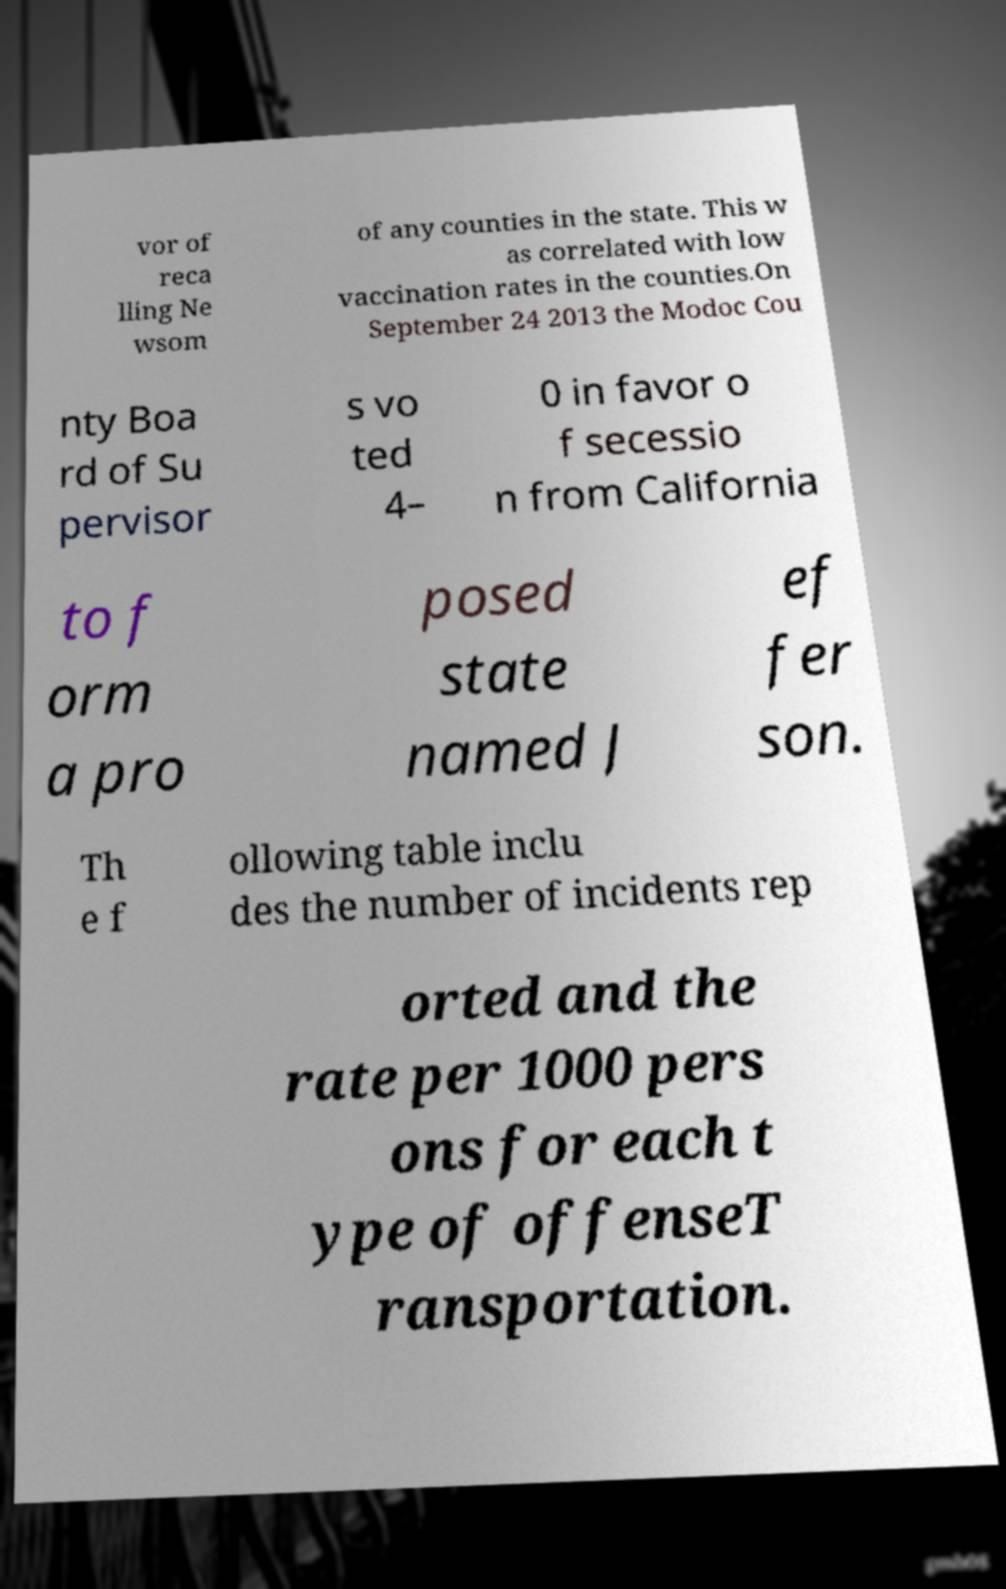Please identify and transcribe the text found in this image. vor of reca lling Ne wsom of any counties in the state. This w as correlated with low vaccination rates in the counties.On September 24 2013 the Modoc Cou nty Boa rd of Su pervisor s vo ted 4– 0 in favor o f secessio n from California to f orm a pro posed state named J ef fer son. Th e f ollowing table inclu des the number of incidents rep orted and the rate per 1000 pers ons for each t ype of offenseT ransportation. 